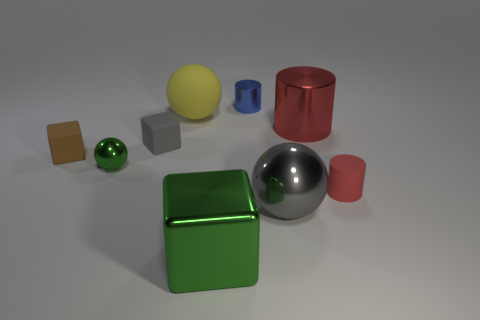Subtract all big blocks. How many blocks are left? 2 Subtract all gray blocks. How many blocks are left? 2 Subtract all cyan matte objects. Subtract all small gray matte things. How many objects are left? 8 Add 8 yellow matte spheres. How many yellow matte spheres are left? 9 Add 3 large green metallic blocks. How many large green metallic blocks exist? 4 Subtract 0 blue cubes. How many objects are left? 9 Subtract all blocks. How many objects are left? 6 Subtract 2 cylinders. How many cylinders are left? 1 Subtract all gray cylinders. Subtract all red cubes. How many cylinders are left? 3 Subtract all red blocks. How many red cylinders are left? 2 